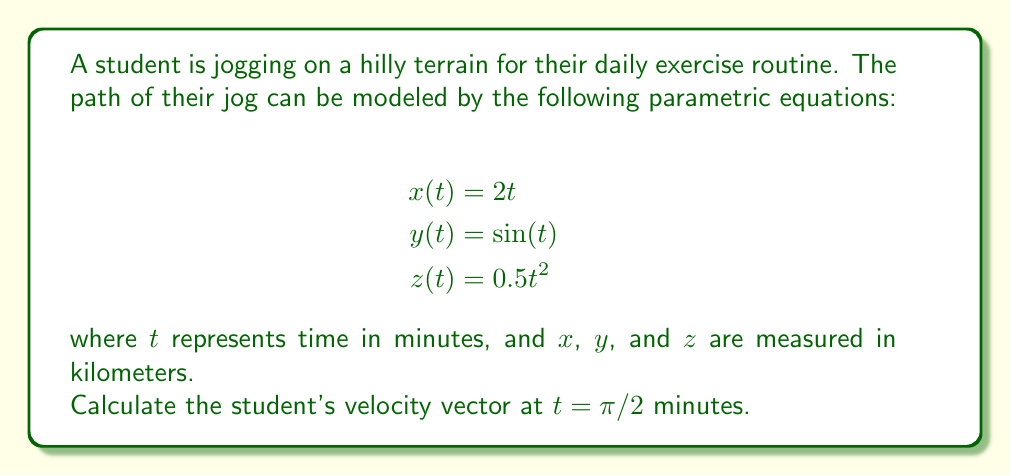Help me with this question. To find the velocity vector at a specific time, we need to differentiate each component of the position vector with respect to $t$. The velocity vector is given by:

$$\vec{v}(t) = \langle x'(t), y'(t), z'(t) \rangle$$

Let's differentiate each component:

1. $x'(t) = \frac{d}{dt}(2t) = 2$

2. $y'(t) = \frac{d}{dt}(\sin(t)) = \cos(t)$

3. $z'(t) = \frac{d}{dt}(0.5t^2) = t$

Now, we have the general velocity vector:

$$\vec{v}(t) = \langle 2, \cos(t), t \rangle$$

To find the velocity vector at $t = \pi/2$, we substitute this value:

$$\vec{v}(\pi/2) = \langle 2, \cos(\pi/2), \pi/2 \rangle$$

Simplify:
- $\cos(\pi/2) = 0$
- $\pi/2 \approx 1.57$

Therefore, the velocity vector at $t = \pi/2$ is:

$$\vec{v}(\pi/2) = \langle 2, 0, 1.57 \rangle$$

This vector represents the student's velocity in km/min at $t = \pi/2$ minutes into their jog.
Answer: $$\vec{v}(\pi/2) = \langle 2, 0, 1.57 \rangle \text{ km/min}$$ 